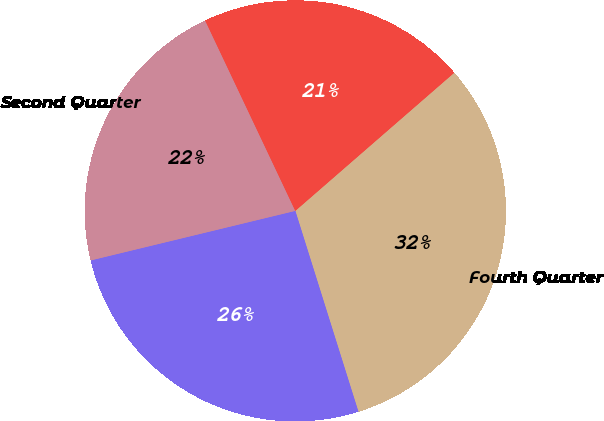<chart> <loc_0><loc_0><loc_500><loc_500><pie_chart><fcel>Fourth Quarter<fcel>Third Quarter<fcel>Second Quarter<fcel>First Quarter<nl><fcel>31.54%<fcel>26.06%<fcel>21.74%<fcel>20.65%<nl></chart> 